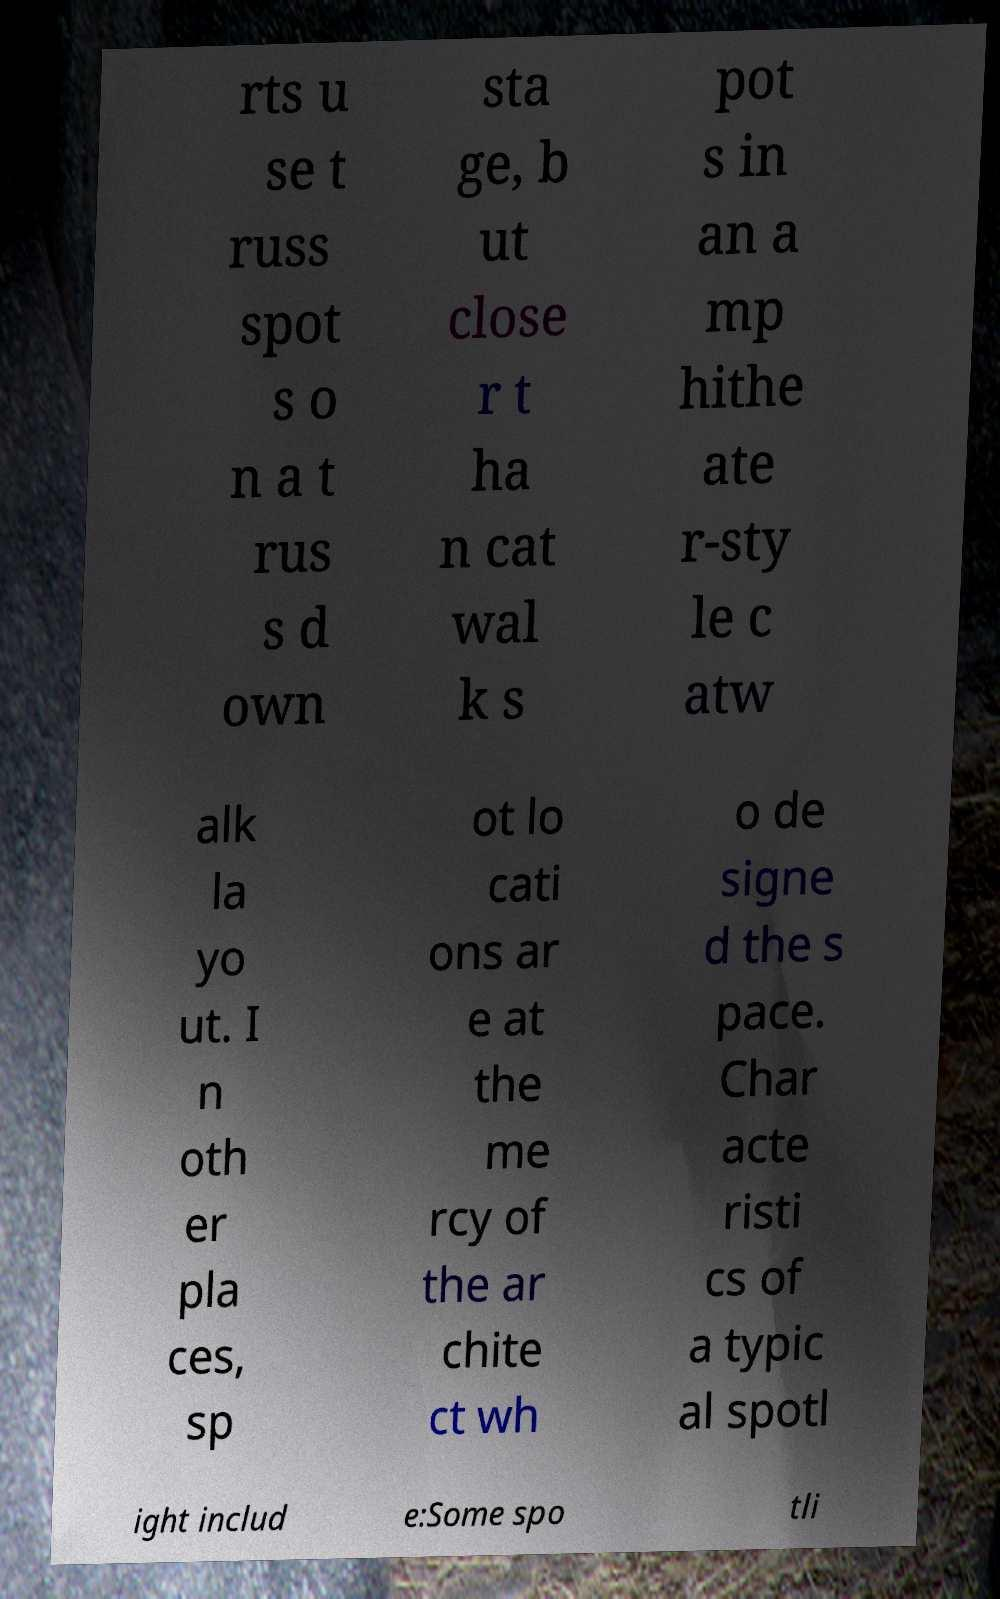What messages or text are displayed in this image? I need them in a readable, typed format. rts u se t russ spot s o n a t rus s d own sta ge, b ut close r t ha n cat wal k s pot s in an a mp hithe ate r-sty le c atw alk la yo ut. I n oth er pla ces, sp ot lo cati ons ar e at the me rcy of the ar chite ct wh o de signe d the s pace. Char acte risti cs of a typic al spotl ight includ e:Some spo tli 